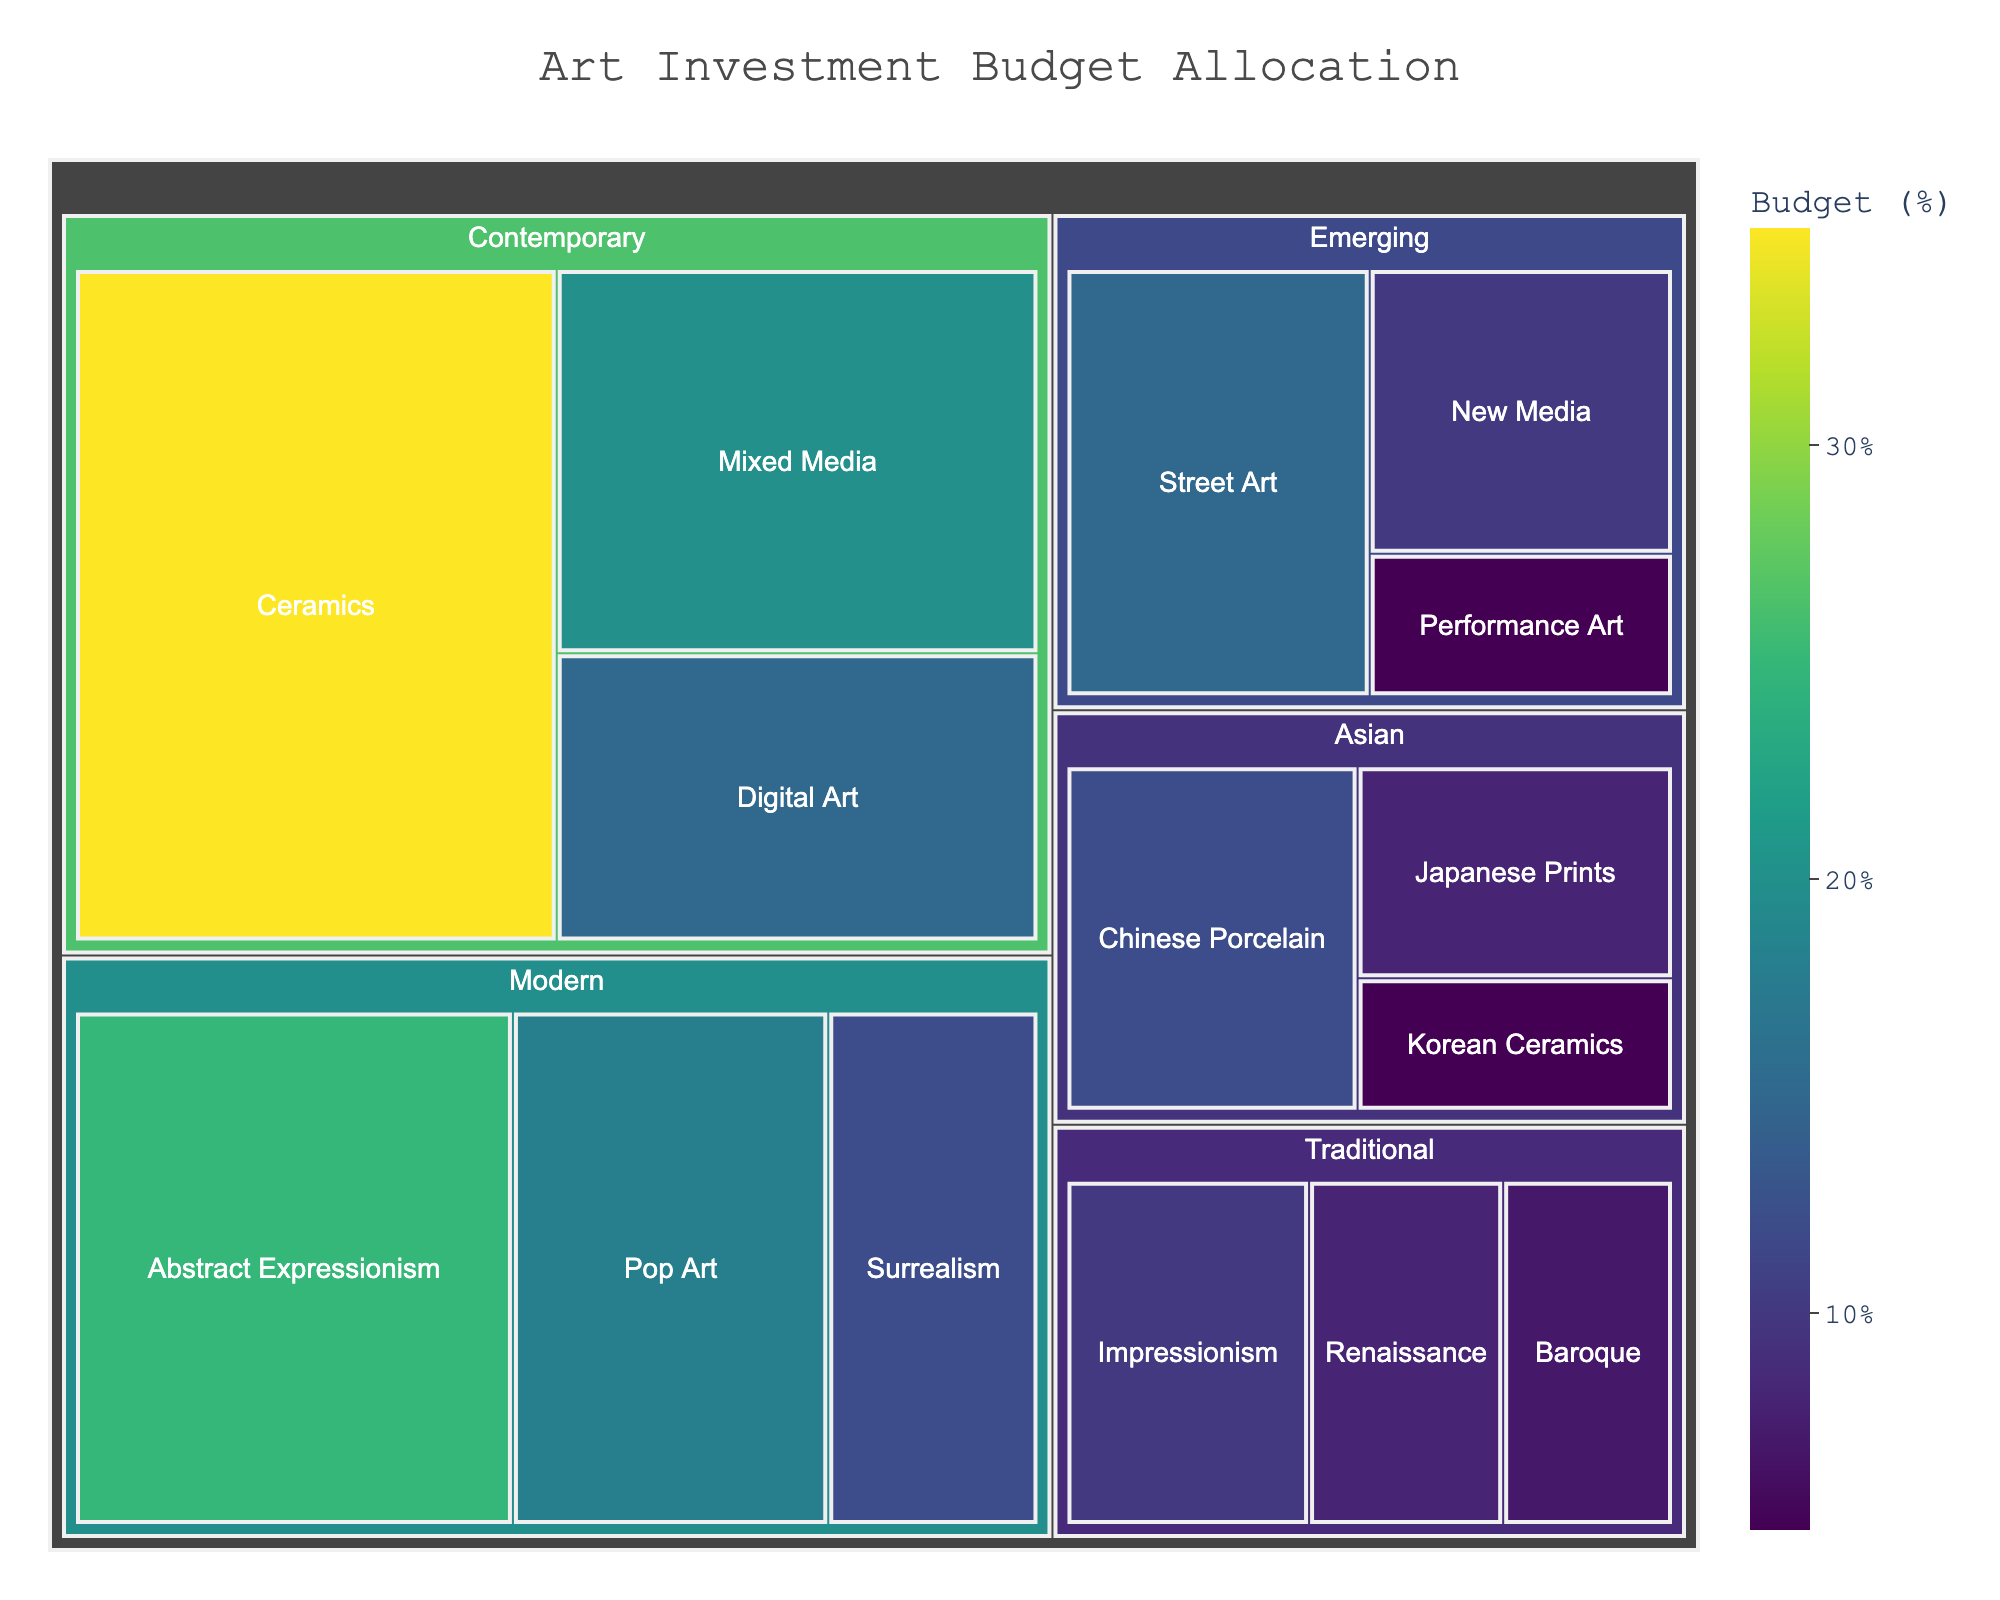What is the title of the treemap? The title is centrally placed at the top of the treemap and written in a larger font compared to other text elements.
Answer: Art Investment Budget Allocation How much of the budget is allocated to Contemporary Ceramics? The label on the treemap segment for Contemporary Ceramics shows the budget allocation percentage.
Answer: 35% Which art style has the smallest budget allocation? The segment with the smallest size and labeled accordingly in the treemap indicates the smallest budget allocation.
Answer: Traditional Baroque What is the total budget allocation for Modern art styles? Sum the values allocated to Abstract Expressionism, Pop Art, and Surrealism within the Modern category.
Answer: 55% How does the budget allocation for Emerging art styles compare to Traditional art styles? Sum the values for Emerging (Street Art, New Media, Performance Art) and Traditional (Impressionism, Renaissance, Baroque) categories and compare them. Emerging is 30%, and Traditional is 25%.
Answer: Emerging has a higher allocation Which art movement within Contemporary has the second highest budget allocation? Within the Contemporary category, compare the three values: Ceramics, Mixed Media, and Digital Art. The second highest is Mixed Media.
Answer: Mixed Media What is the combined budget allocation for all Asian art categories? Sum the values for Chinese Porcelain, Japanese Prints, and Korean Ceramics within the Asian category.
Answer: 25% Are more funds allocated to Contemporary Mixed Media or Modern Pop Art? Compare the budget values for Contemporary Mixed Media (20%) and Modern Pop Art (18%).
Answer: Contemporary Mixed Media Which art category has the most segments within it? Count the number of subcategories under each main category in the treemap. Contemporary and Emerging both have three subcategories.
Answer: Contemporary and Emerging What percentage of the total budget is allocated to Ceramics (both Contemporary and Korean)? Add the values for Contemporary Ceramics and Korean Ceramics. 35% (Contemporary) + 5% (Korean) = 40%
Answer: 40% 